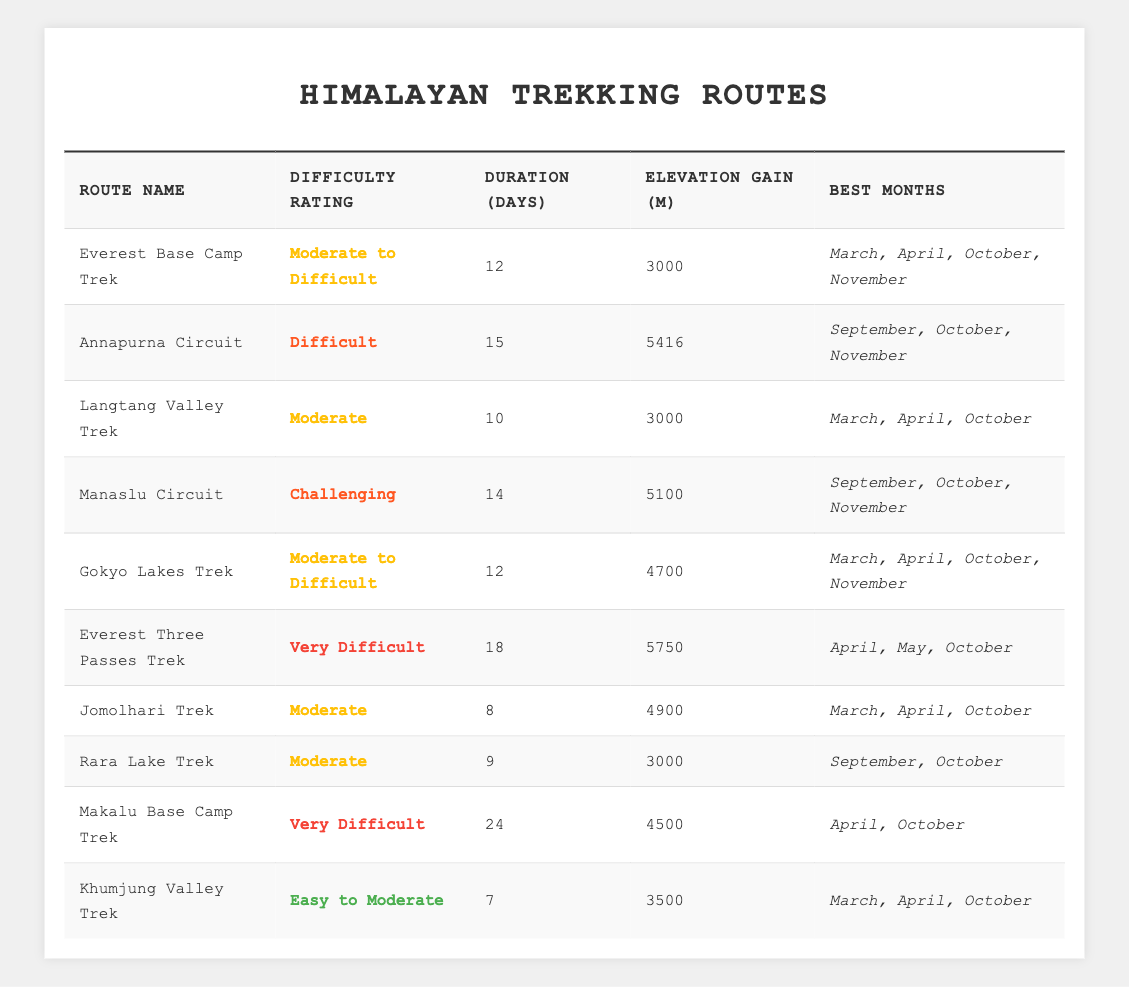What is the difficulty rating for the Everest Base Camp Trek? The table lists Everest Base Camp Trek under the "Difficulty Rating" column, which states it is rated as "Moderate to Difficult".
Answer: Moderate to Difficult How many days does the Annapurna Circuit Trek take? By checking the "Duration (Days)" column in the table, it shows that the Annapurna Circuit Trek takes 15 days.
Answer: 15 days Which trek has the highest elevation gain? The "Elevation Gain (m)" column reveals that the Annapurna Circuit has the highest elevation gain of 5416 meters.
Answer: Annapurna Circuit What are the best months for the Gokyo Lakes Trek? The "Best Months" column indicates that the best months for the Gokyo Lakes Trek are March, April, October, and November.
Answer: March, April, October, November Is the Manaslu Circuit rated as Difficult? The "Difficulty Rating" for the Manaslu Circuit is "Challenging", which is not equivalent to "Difficult". Therefore, the answer is false.
Answer: No How many trekking routes have a difficulty rating of "Moderate"? By scanning the "Difficulty Rating" column, I can see that Langtang Valley Trek, Gokyo Lakes Trek, Jomolhari Trek, and Rara Lake Trek are rated "Moderate". That totals four treks.
Answer: 4 What is the average duration of the treks listed? The total durations are 12 + 15 + 10 + 14 + 12 + 18 + 8 + 9 + 24 + 7 = 139 days. There are 10 treks, so the average duration is 139/10 = 13.9 days.
Answer: 13.9 days Are there any treks rated as "Very Difficult"? I look at the "Difficulty Rating" column; both the Everest Three Passes Trek and Makalu Base Camp Trek are rated as "Very Difficult". Therefore, the answer is yes.
Answer: Yes What is the total elevation gain for all treks rated "Easy to Moderate"? The only trek listed under "Easy to Moderate" is the Khumjung Valley Trek, which has an elevation gain of 3500 meters. Since it's the only one, the total is 3500 meters.
Answer: 3500 meters Which trek has the longest duration and how many days is it? The table shows that the Makalu Base Camp Trek has the longest duration of 24 days, as indicated in the "Duration (Days)" column.
Answer: Makalu Base Camp Trek, 24 days 